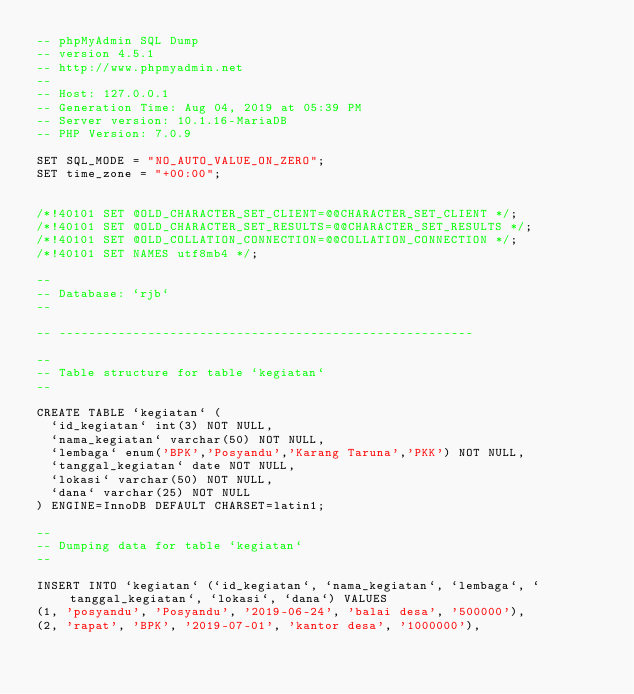Convert code to text. <code><loc_0><loc_0><loc_500><loc_500><_SQL_>-- phpMyAdmin SQL Dump
-- version 4.5.1
-- http://www.phpmyadmin.net
--
-- Host: 127.0.0.1
-- Generation Time: Aug 04, 2019 at 05:39 PM
-- Server version: 10.1.16-MariaDB
-- PHP Version: 7.0.9

SET SQL_MODE = "NO_AUTO_VALUE_ON_ZERO";
SET time_zone = "+00:00";


/*!40101 SET @OLD_CHARACTER_SET_CLIENT=@@CHARACTER_SET_CLIENT */;
/*!40101 SET @OLD_CHARACTER_SET_RESULTS=@@CHARACTER_SET_RESULTS */;
/*!40101 SET @OLD_COLLATION_CONNECTION=@@COLLATION_CONNECTION */;
/*!40101 SET NAMES utf8mb4 */;

--
-- Database: `rjb`
--

-- --------------------------------------------------------

--
-- Table structure for table `kegiatan`
--

CREATE TABLE `kegiatan` (
  `id_kegiatan` int(3) NOT NULL,
  `nama_kegiatan` varchar(50) NOT NULL,
  `lembaga` enum('BPK','Posyandu','Karang Taruna','PKK') NOT NULL,
  `tanggal_kegiatan` date NOT NULL,
  `lokasi` varchar(50) NOT NULL,
  `dana` varchar(25) NOT NULL
) ENGINE=InnoDB DEFAULT CHARSET=latin1;

--
-- Dumping data for table `kegiatan`
--

INSERT INTO `kegiatan` (`id_kegiatan`, `nama_kegiatan`, `lembaga`, `tanggal_kegiatan`, `lokasi`, `dana`) VALUES
(1, 'posyandu', 'Posyandu', '2019-06-24', 'balai desa', '500000'),
(2, 'rapat', 'BPK', '2019-07-01', 'kantor desa', '1000000'),</code> 